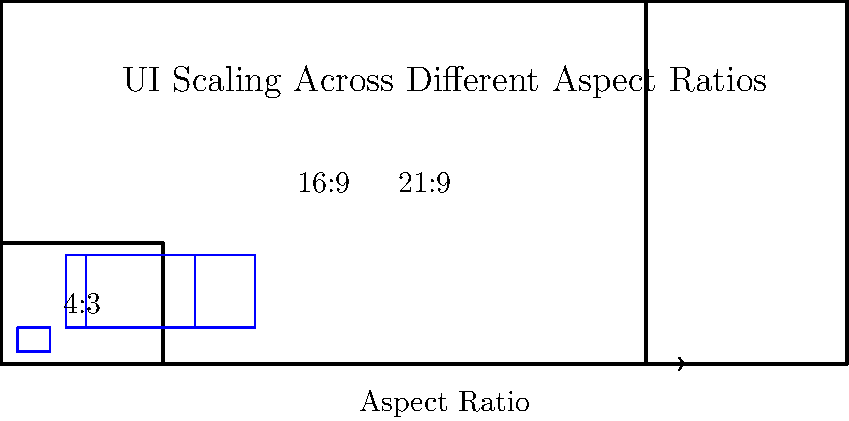In the diagram above, a UI element is shown on screens with different aspect ratios. If the UI element occupies 20% of the screen width on the 4:3 display, what percentage of the screen width would it occupy on the 21:9 display to maintain the same physical size relative to the overall screen width? Assume the 21:9 screen has the same physical width as the 4:3 screen. To solve this problem, we need to follow these steps:

1. Understand that maintaining the same physical size means the UI element should occupy the same absolute width across all screens.

2. Calculate the relative width of the UI element on the 4:3 screen:
   - Given: The UI element occupies 20% of the 4:3 screen width.
   - Relative width = 20% = 0.2

3. Calculate the width ratio between 21:9 and 4:3 screens:
   - 4:3 aspect ratio: $\frac{4}{3}$
   - 21:9 aspect ratio: $\frac{21}{9} = \frac{7}{3}$
   - Width ratio = $\frac{7/3}{4/3} = \frac{7}{4}$

4. Calculate the new relative width on the 21:9 screen:
   - New relative width = Original relative width ÷ Width ratio
   - New relative width = $0.2 \div \frac{7}{4} = 0.2 \times \frac{4}{7} \approx 0.1143$

5. Convert the result to a percentage:
   0.1143 × 100% ≈ 11.43%

Therefore, to maintain the same physical size relative to the overall screen width, the UI element should occupy approximately 11.43% of the screen width on the 21:9 display.
Answer: 11.43% 